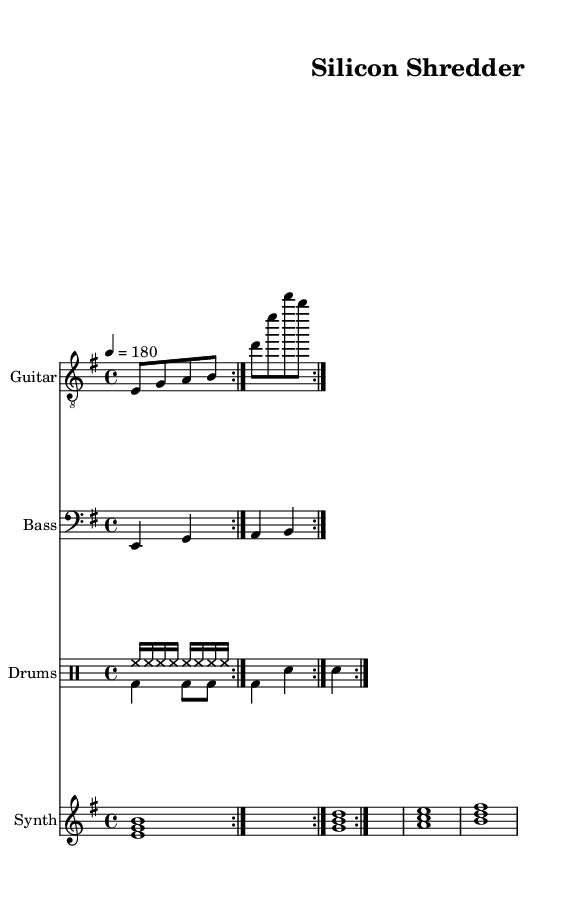What is the key signature of this music? The key signature is E minor, which has one sharp (F#) and indicates the tonality of the piece.
Answer: E minor What is the time signature of the music? The time signature is 4/4, meaning there are four beats in each measure and a quarter note receives one beat.
Answer: 4/4 What is the tempo marking? The tempo marking indicates a speed of 180 beats per minute (BPM), suggesting a fast-paced, energetic rhythm characteristic of industrial metal.
Answer: 180 How many measures are in the guitar part? The guitar part consists of 8 measures, as indicated by the use of the repeat sign that instructs to play the riff twice each consisting of 4 measures.
Answer: 8 What instruments are included in this score? The score includes a Guitar, Bass, Drums, and Synth, all indicated by the labels in the staff headings.
Answer: Guitar, Bass, Drums, Synth Which instrument features the full chord progression? The Synth instrument features the full chord progression visible in its staff, showing a series of triads that contribute to the harmonic structure of the piece.
Answer: Synth What drum patterns appear in the score? The drum patterns consist of various combinations of hi-hats and bass drums, with the Up pattern focusing on continuous hi-hats and the Down pattern incorporating bass and snare hits for added aggression.
Answer: Hi-hat and bass drum 